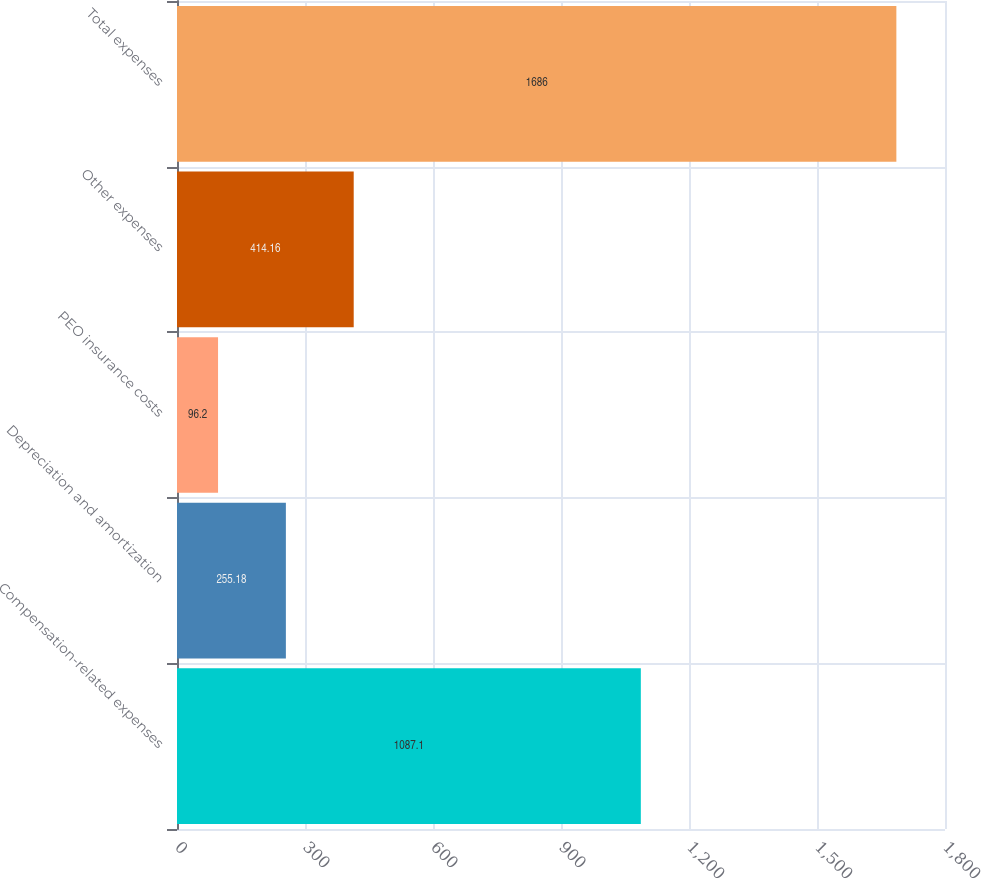<chart> <loc_0><loc_0><loc_500><loc_500><bar_chart><fcel>Compensation-related expenses<fcel>Depreciation and amortization<fcel>PEO insurance costs<fcel>Other expenses<fcel>Total expenses<nl><fcel>1087.1<fcel>255.18<fcel>96.2<fcel>414.16<fcel>1686<nl></chart> 